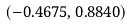Convert formula to latex. <formula><loc_0><loc_0><loc_500><loc_500>( - 0 . 4 6 7 5 , 0 . 8 8 4 0 )</formula> 